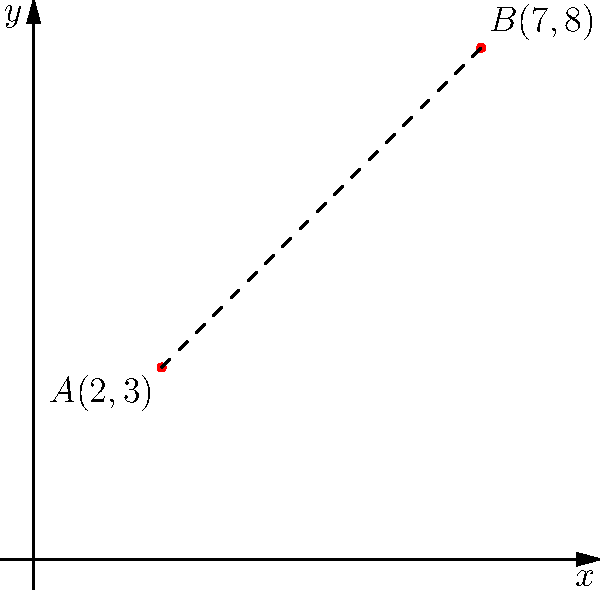Imagine you're plotting the journey of a curious explorer on a coordinate plane. The explorer starts at point $A(2,3)$ and ends at point $B(7,8)$. Using the distance formula, can you determine how far the explorer traveled in a straight line? Let's embark on this mathematical adventure together!

1) First, recall the distance formula:
   $$d = \sqrt{(x_2-x_1)^2 + (y_2-y_1)^2}$$

2) We have two points:
   $A(x_1,y_1) = (2,3)$ and $B(x_2,y_2) = (7,8)$

3) Let's plug these into our formula:
   $$d = \sqrt{(7-2)^2 + (8-3)^2}$$

4) Simplify inside the parentheses:
   $$d = \sqrt{5^2 + 5^2}$$

5) Calculate the squares:
   $$d = \sqrt{25 + 25}$$

6) Add inside the square root:
   $$d = \sqrt{50}$$

7) Simplify the square root:
   $$d = 5\sqrt{2}$$

And there we have it! Our explorer traveled a distance of $5\sqrt{2}$ units.
Answer: $5\sqrt{2}$ units 